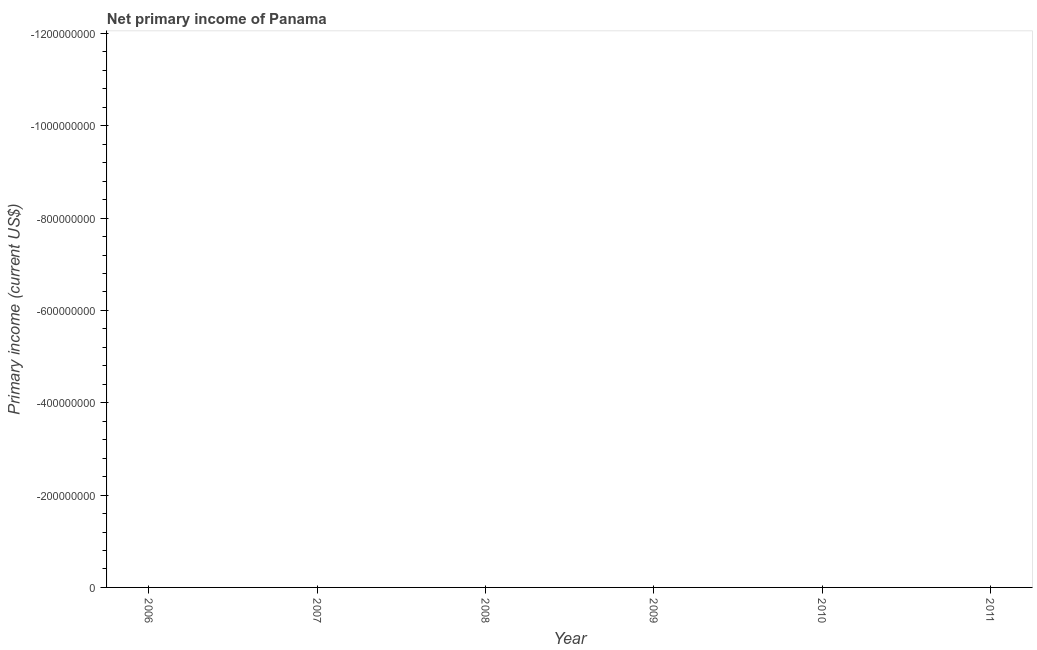What is the amount of primary income in 2011?
Give a very brief answer. 0. How many years are there in the graph?
Give a very brief answer. 6. Are the values on the major ticks of Y-axis written in scientific E-notation?
Give a very brief answer. No. Does the graph contain grids?
Provide a succinct answer. No. What is the title of the graph?
Give a very brief answer. Net primary income of Panama. What is the label or title of the X-axis?
Offer a terse response. Year. What is the label or title of the Y-axis?
Your response must be concise. Primary income (current US$). What is the Primary income (current US$) in 2011?
Your answer should be compact. 0. 